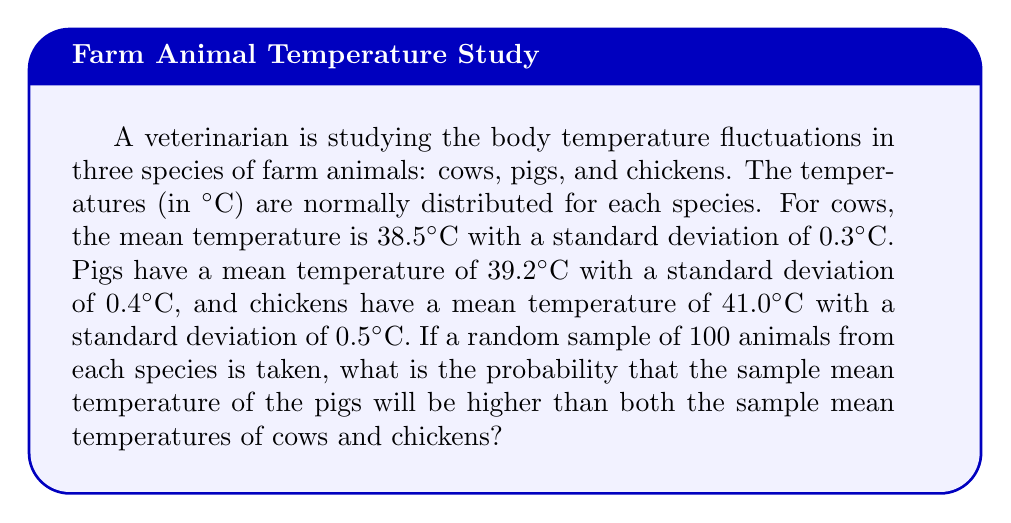Provide a solution to this math problem. To solve this problem, we need to follow these steps:

1) First, recall that for a normal distribution, the sampling distribution of the mean is also normal, with the same mean but a standard deviation reduced by a factor of $\sqrt{n}$, where $n$ is the sample size.

2) For each species, calculate the standard error of the mean:

   Cows: $SE_c = \frac{0.3}{\sqrt{100}} = 0.03$
   Pigs: $SE_p = \frac{0.4}{\sqrt{100}} = 0.04$
   Chickens: $SE_{ch} = \frac{0.5}{\sqrt{100}} = 0.05$

3) Now, we need to find the probability that the pig sample mean is greater than both the cow and chicken sample means. Let's call these events A and B respectively:

   A: Pig mean > Cow mean
   B: Pig mean > Chicken mean

4) For event A:
   $Z_A = \frac{(39.2 - 38.5)}{\sqrt{0.04^2 + 0.03^2}} = \frac{0.7}{0.05} = 14$

5) For event B:
   $Z_B = \frac{(39.2 - 41.0)}{\sqrt{0.04^2 + 0.05^2}} = \frac{-1.8}{0.0641} = -28.08$

6) The probability of A is $P(A) = 1 - \Phi(14) \approx 1$, where $\Phi$ is the standard normal cumulative distribution function.

7) The probability of B is $P(B) = \Phi(-28.08) \approx 0$

8) The probability we're looking for is $P(A \cap B) = P(A) \times P(B)$ (assuming independence), which is approximately 0.
Answer: $\approx 0$ 